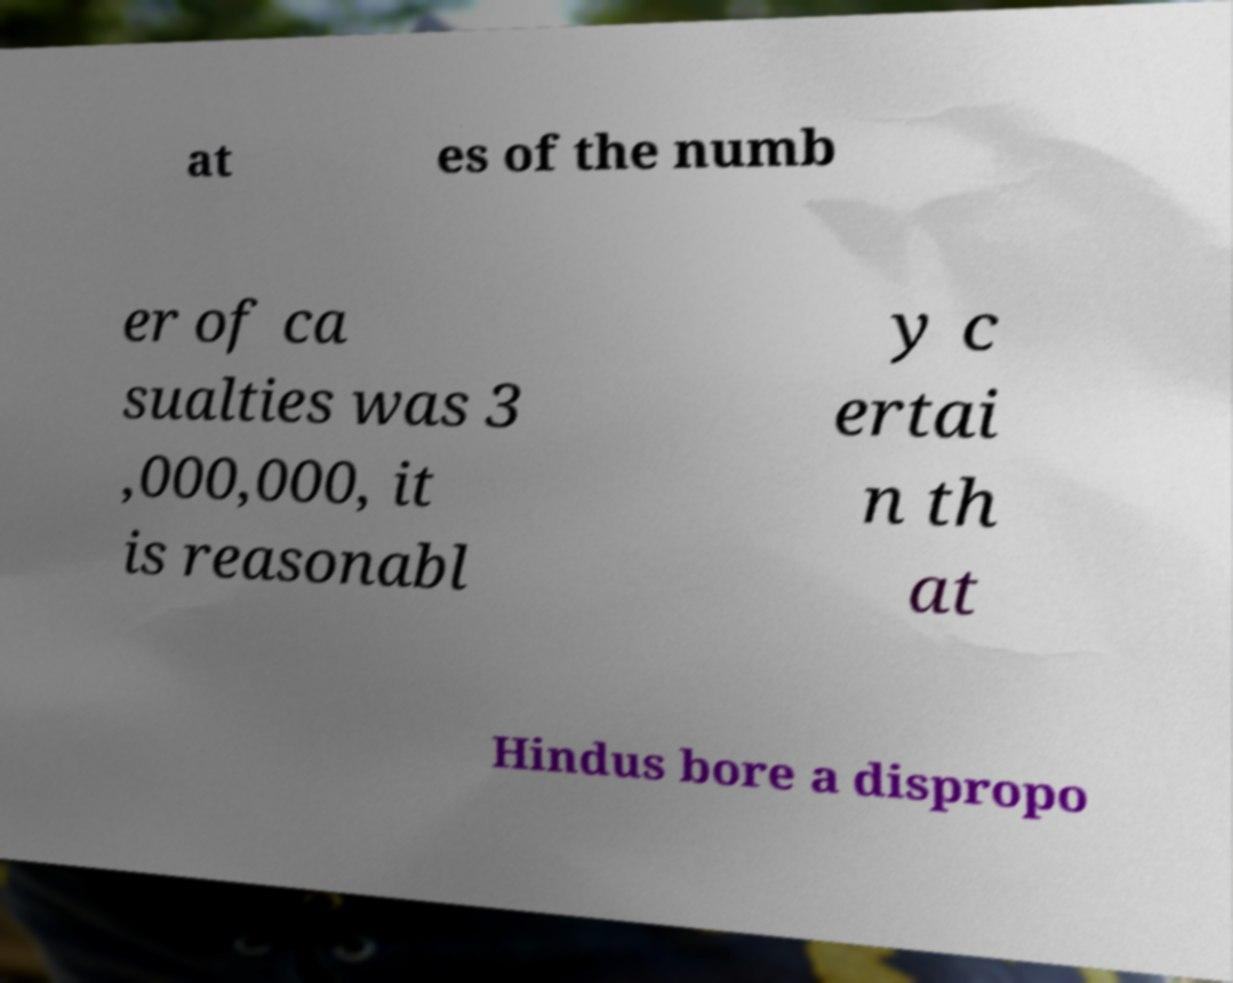Could you extract and type out the text from this image? at es of the numb er of ca sualties was 3 ,000,000, it is reasonabl y c ertai n th at Hindus bore a dispropo 